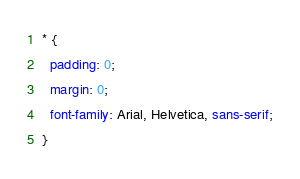<code> <loc_0><loc_0><loc_500><loc_500><_CSS_>* {
  padding: 0;
  margin: 0;
  font-family: Arial, Helvetica, sans-serif;
}
</code> 